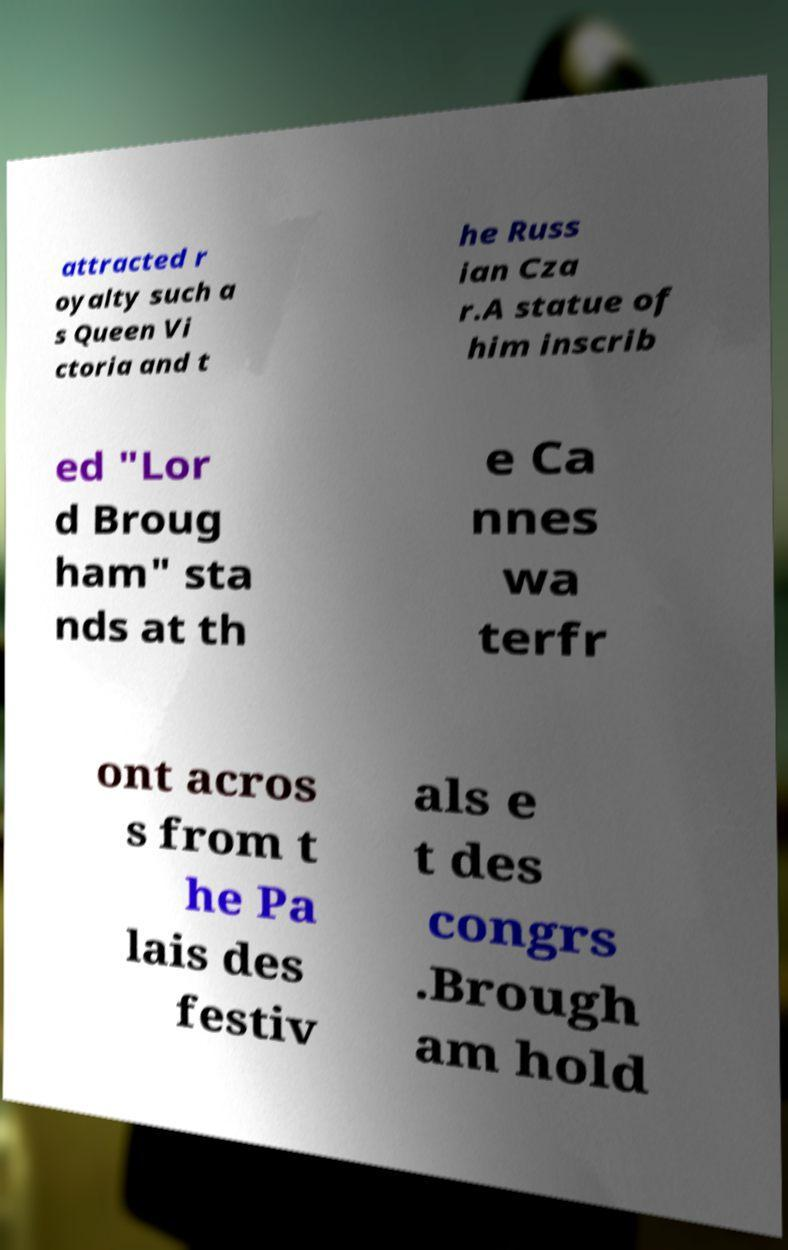Please identify and transcribe the text found in this image. attracted r oyalty such a s Queen Vi ctoria and t he Russ ian Cza r.A statue of him inscrib ed "Lor d Broug ham" sta nds at th e Ca nnes wa terfr ont acros s from t he Pa lais des festiv als e t des congrs .Brough am hold 